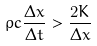Convert formula to latex. <formula><loc_0><loc_0><loc_500><loc_500>\rho c \frac { \Delta x } { \Delta t } > \frac { 2 K } { \Delta x }</formula> 